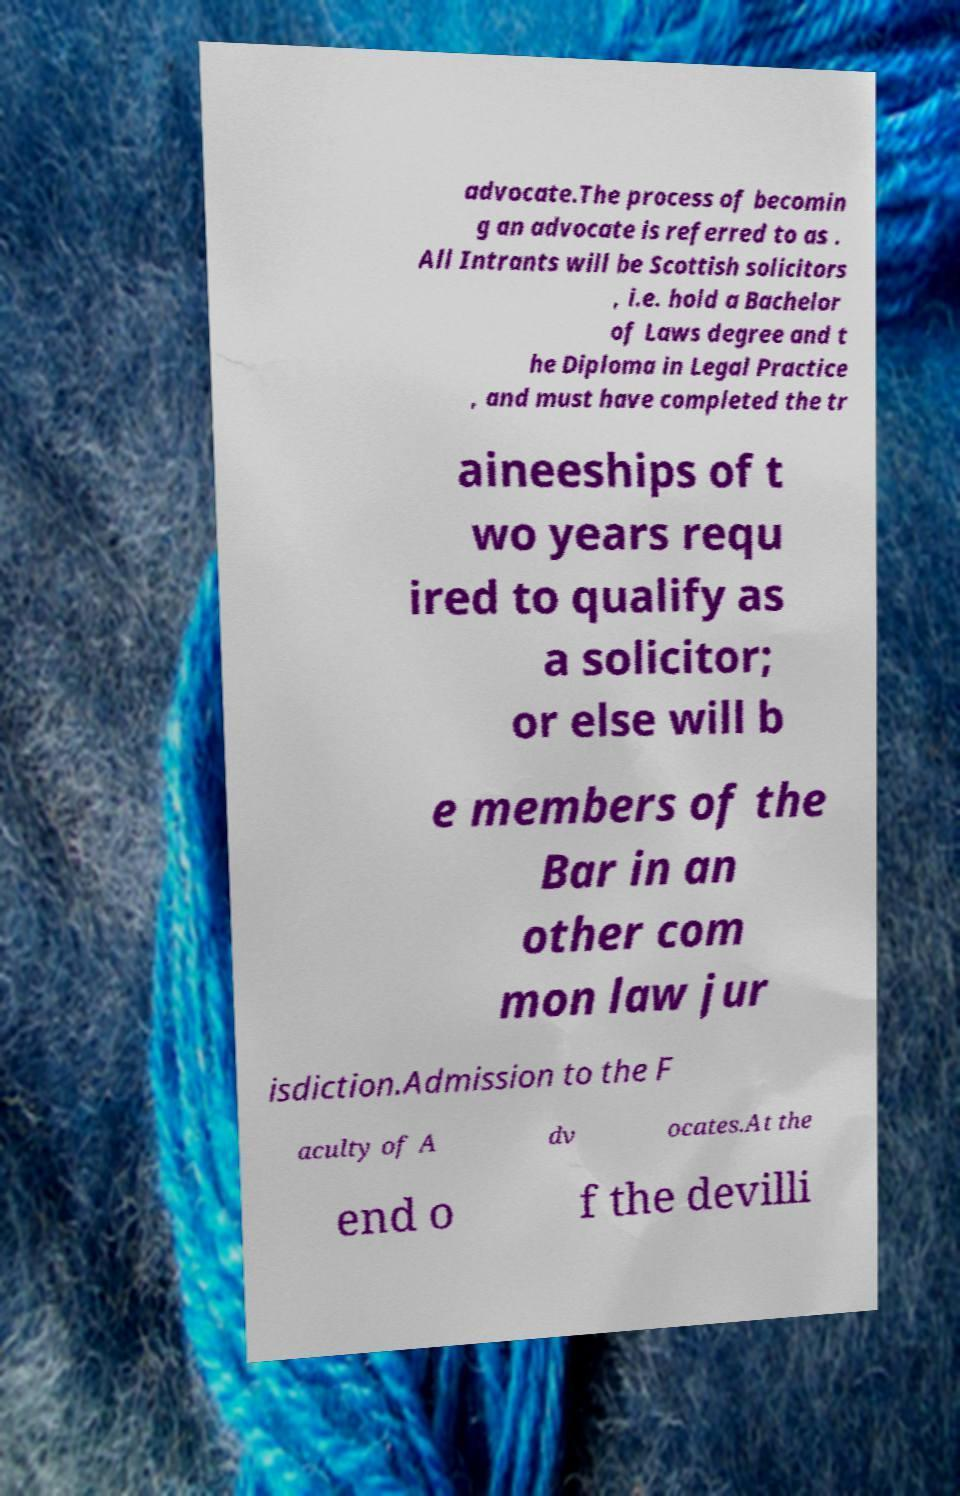Please identify and transcribe the text found in this image. advocate.The process of becomin g an advocate is referred to as . All Intrants will be Scottish solicitors , i.e. hold a Bachelor of Laws degree and t he Diploma in Legal Practice , and must have completed the tr aineeships of t wo years requ ired to qualify as a solicitor; or else will b e members of the Bar in an other com mon law jur isdiction.Admission to the F aculty of A dv ocates.At the end o f the devilli 